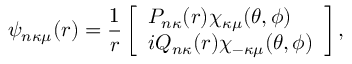<formula> <loc_0><loc_0><loc_500><loc_500>\psi _ { n \kappa \mu } ( r ) = \frac { 1 } { r } \left [ \begin{array} { l } { P _ { n \kappa } ( r ) \chi _ { \kappa \mu } ( \theta , \phi ) } \\ { i Q _ { n \kappa } ( r ) \chi _ { - \kappa \mu } ( \theta , \phi ) } \end{array} \right ] ,</formula> 